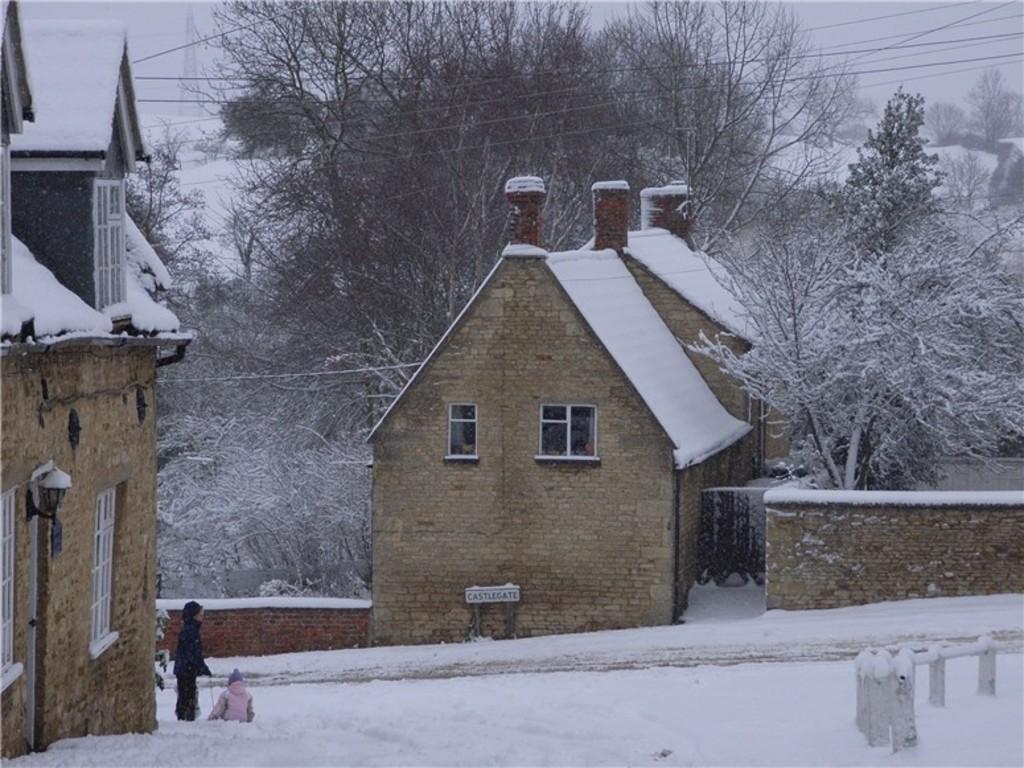How would you summarize this image in a sentence or two? In this image I can see two persons on the snow. In the background I can see few houses in brown and cream color and I can also see few trees and the sky is in white color. 